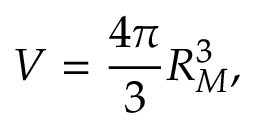Convert formula to latex. <formula><loc_0><loc_0><loc_500><loc_500>V = \frac { 4 \pi } { 3 } R _ { M } ^ { 3 } ,</formula> 